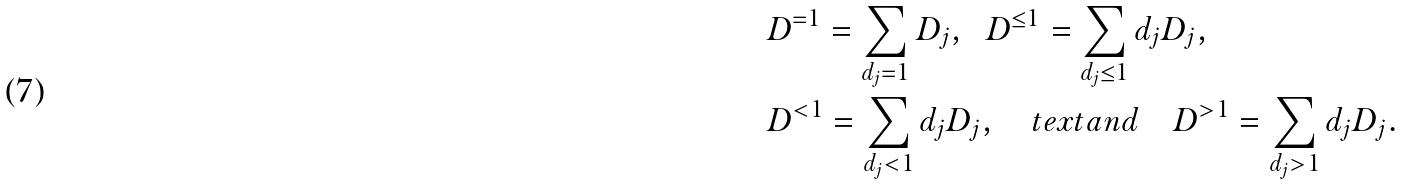<formula> <loc_0><loc_0><loc_500><loc_500>& D ^ { = 1 } = \sum _ { d _ { j } = 1 } D _ { j } , \ \ D ^ { \leq 1 } = \sum _ { d _ { j } \leq 1 } d _ { j } D _ { j } , \\ & D ^ { < 1 } = \sum _ { d _ { j } < 1 } d _ { j } D _ { j } , \quad t e x t { a n d } \quad D ^ { > 1 } = \sum _ { d _ { j } > 1 } d _ { j } D _ { j } .</formula> 